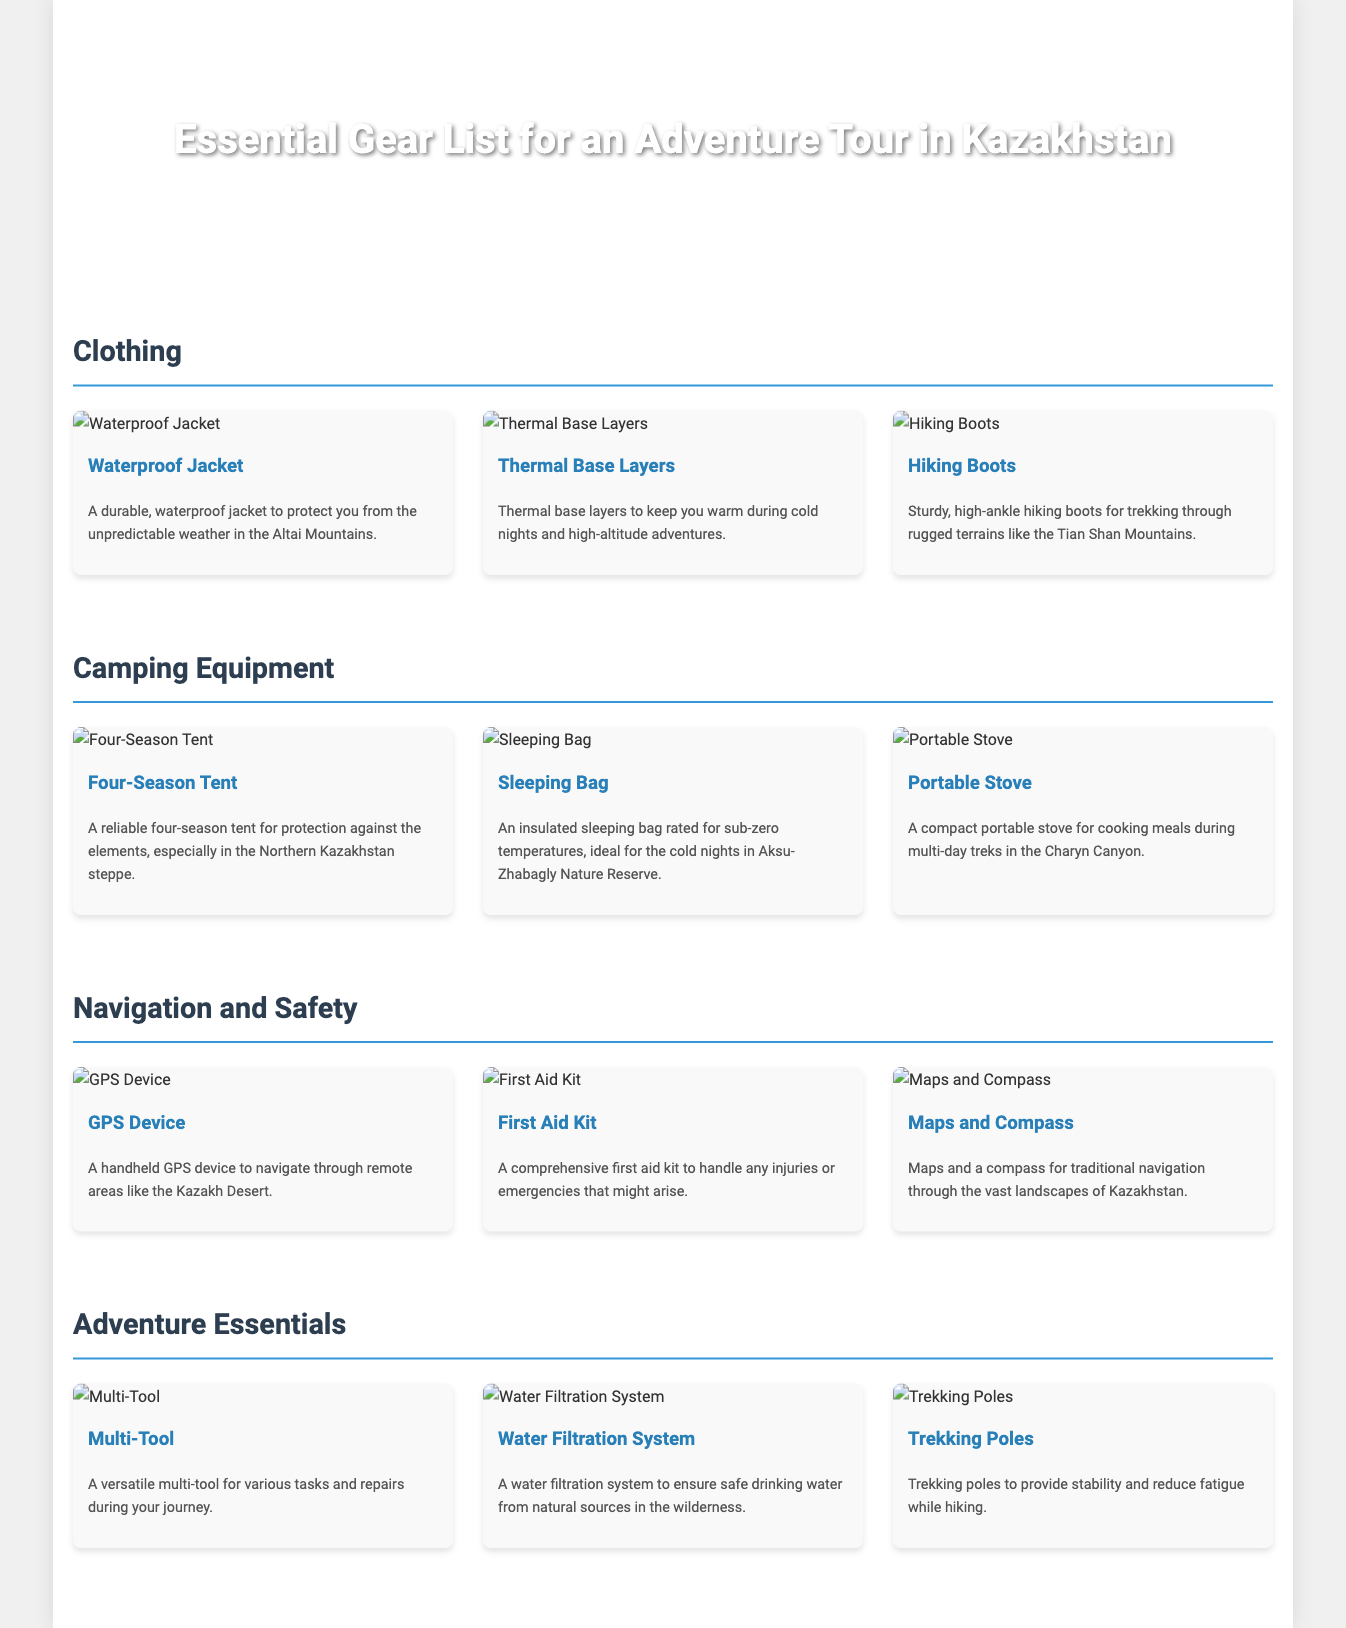what gear is recommended for cold nights? The document mentions a thermal sleeping bag specifically recommended for cold nights.
Answer: Sleeping Bag how many items are listed under Clothing? The document shows three items in the Clothing section.
Answer: Three what type of tent is suggested for camping? The document mentions a reliable four-season tent for protection.
Answer: Four-Season Tent which gear is essential for cooking meals during treks? The portable stove is indicated as necessary for cooking meals.
Answer: Portable Stove what item is provided for navigation in remote areas? A handheld GPS device is suggested for navigation through remote areas.
Answer: GPS Device which section contains a multi-tool? The multi-tool is listed in the Adventure Essentials section.
Answer: Adventure Essentials what item helps to ensure safe drinking water? The document references a water filtration system that ensures safe drinking water.
Answer: Water Filtration System how many items are in the Navigation and Safety section? There are three items listed in the Navigation and Safety section of the document.
Answer: Three what footwear is recommended for trekking? Sturdy, high-ankle hiking boots are recommended for trekking.
Answer: Hiking Boots 